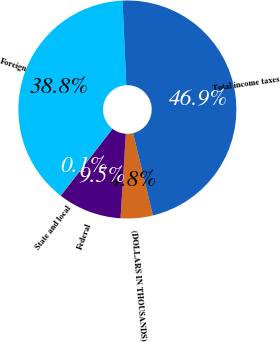Convert chart to OTSL. <chart><loc_0><loc_0><loc_500><loc_500><pie_chart><fcel>(DOLLARS IN THOUSANDS)<fcel>Federal<fcel>State and local<fcel>Foreign<fcel>Total income taxes<nl><fcel>4.76%<fcel>9.45%<fcel>0.08%<fcel>38.76%<fcel>46.94%<nl></chart> 